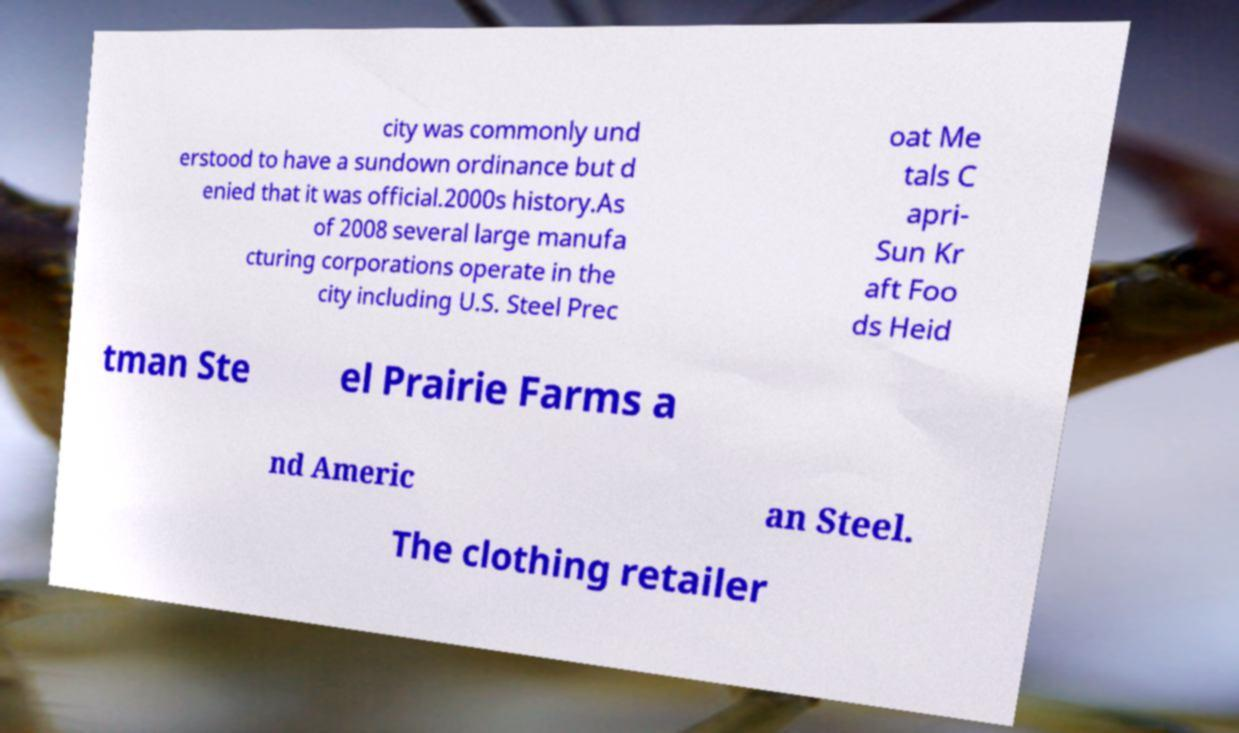Please identify and transcribe the text found in this image. city was commonly und erstood to have a sundown ordinance but d enied that it was official.2000s history.As of 2008 several large manufa cturing corporations operate in the city including U.S. Steel Prec oat Me tals C apri- Sun Kr aft Foo ds Heid tman Ste el Prairie Farms a nd Americ an Steel. The clothing retailer 